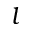Convert formula to latex. <formula><loc_0><loc_0><loc_500><loc_500>l</formula> 